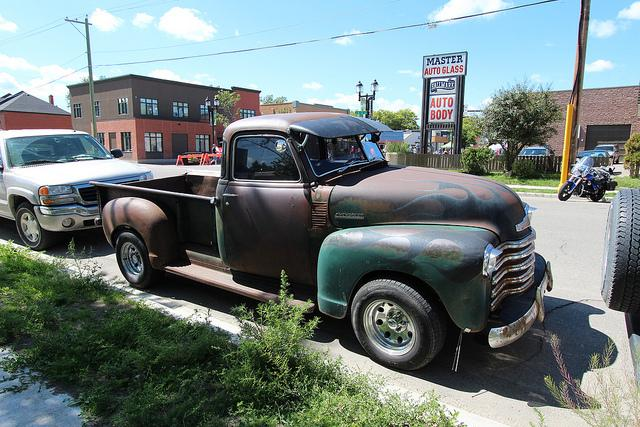What sort of business are the autos in all likelihood closest to? auto body 